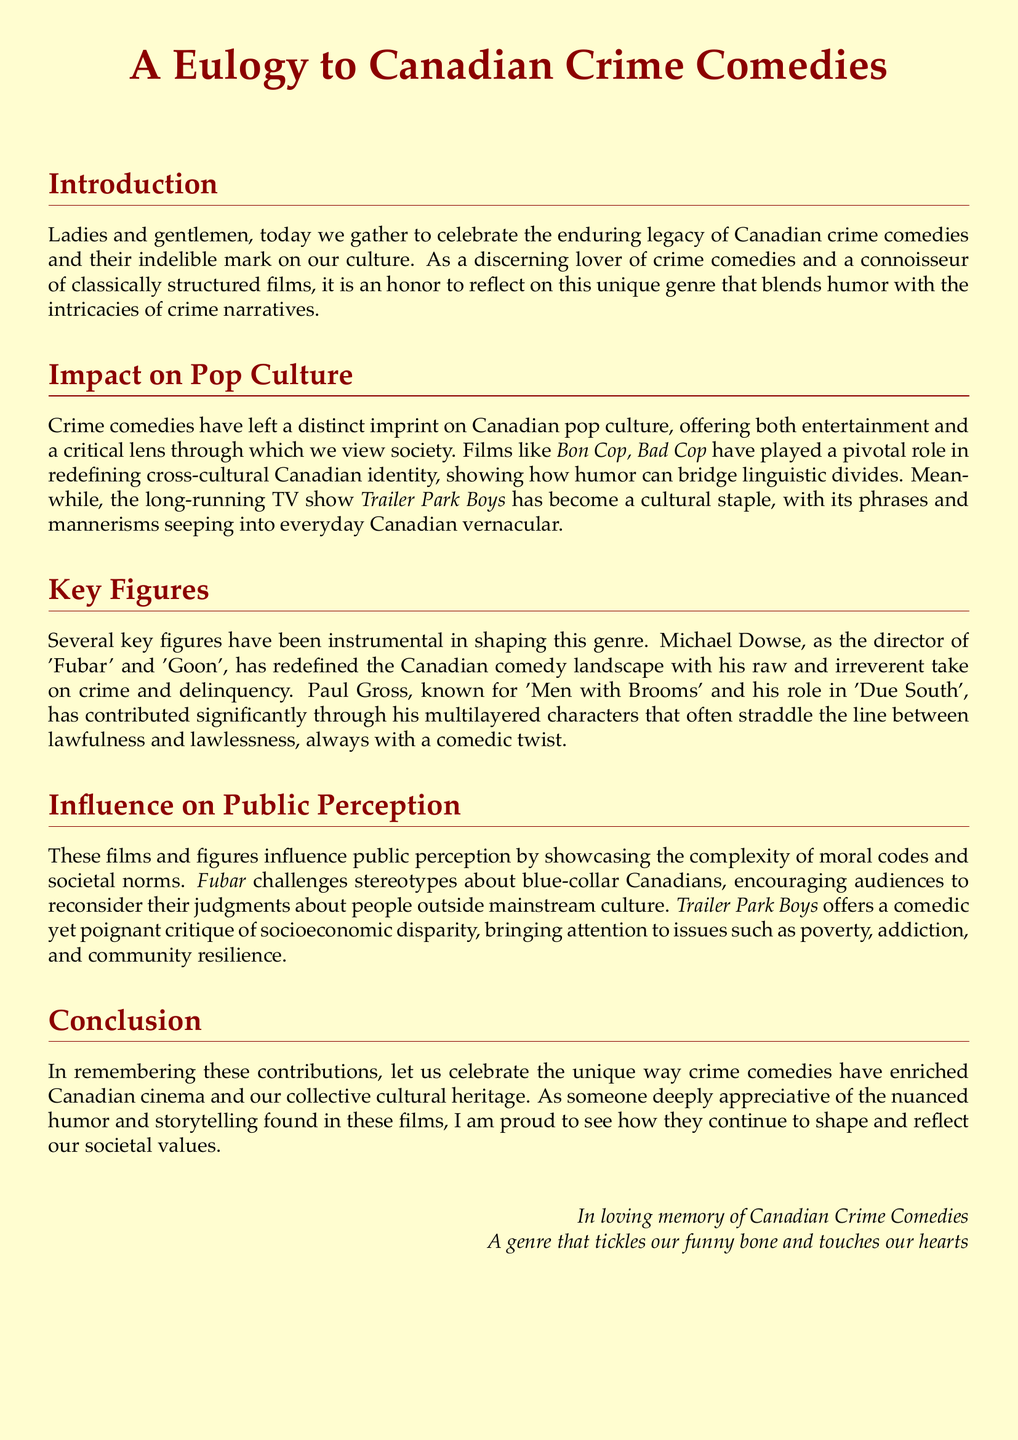What is the title of the document? The title of the document is given at the beginning and is central to the theme of the eulogy.
Answer: A Eulogy to Canadian Crime Comedies Who directed the film 'Fubar'? The document mentions Michael Dowse as the director of 'Fubar'.
Answer: Michael Dowse What notable TV show is mentioned in the eulogy? The eulogy references a TV show that has become a cultural staple in Canada.
Answer: Trailer Park Boys Which film is highlighted for redefining cross-cultural Canadian identity? The document states that 'Bon Cop, Bad Cop' plays a pivotal role in this aspect.
Answer: Bon Cop, Bad Cop What genre does the eulogy focus on? The eulogy is concerned with a specific genre in Canadian cinema.
Answer: Crime comedies What themes do 'Fubar' and 'Trailer Park Boys' address? The document notes that these works bring attention to issues like socioeconomic disparity and moral complexities.
Answer: Poverty, addiction, and community resilience Who is known for the film 'Men with Brooms'? Paul Gross is recognized for his contribution to this film, according to the document.
Answer: Paul Gross What is the tone of the eulogy? The tone is reflective and appreciative of the impact of a genre on culture and society.
Answer: Celebratory 